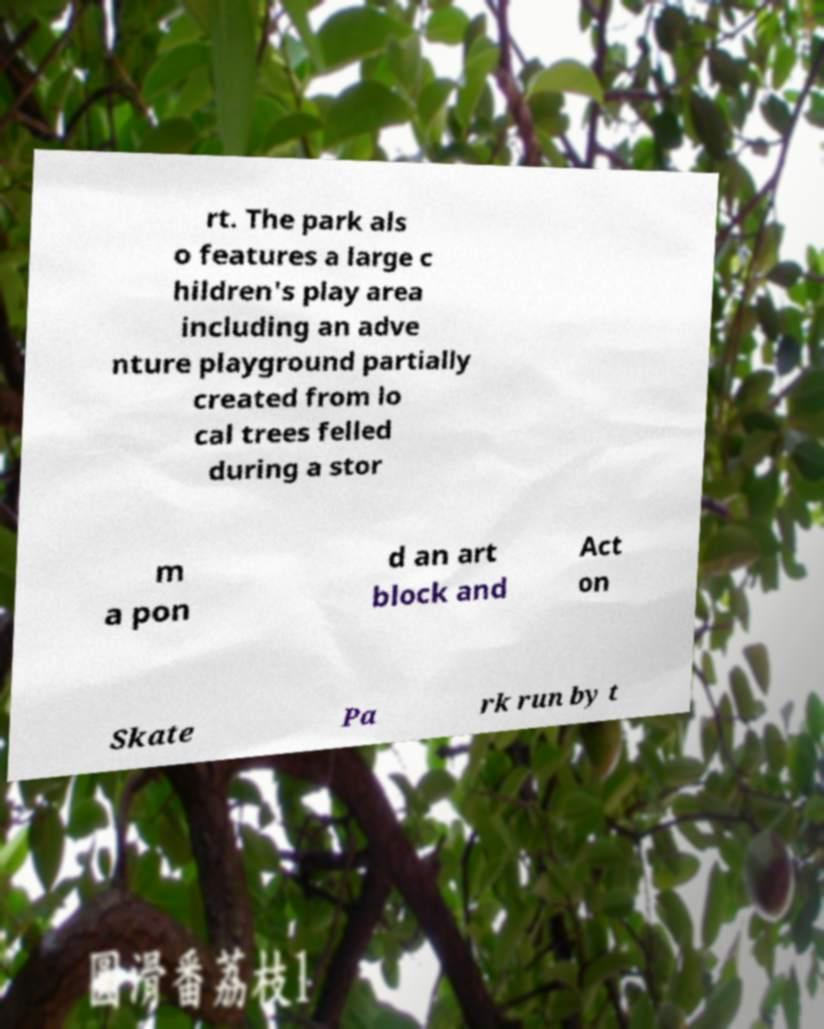Please identify and transcribe the text found in this image. rt. The park als o features a large c hildren's play area including an adve nture playground partially created from lo cal trees felled during a stor m a pon d an art block and Act on Skate Pa rk run by t 